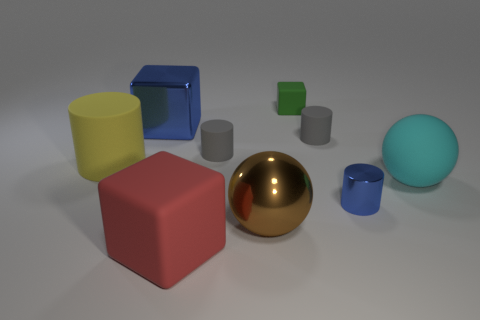Subtract all cylinders. How many objects are left? 5 Add 8 large red metallic balls. How many large red metallic balls exist? 8 Subtract 0 gray blocks. How many objects are left? 9 Subtract all big cyan objects. Subtract all cyan rubber objects. How many objects are left? 7 Add 6 large red matte things. How many large red matte things are left? 7 